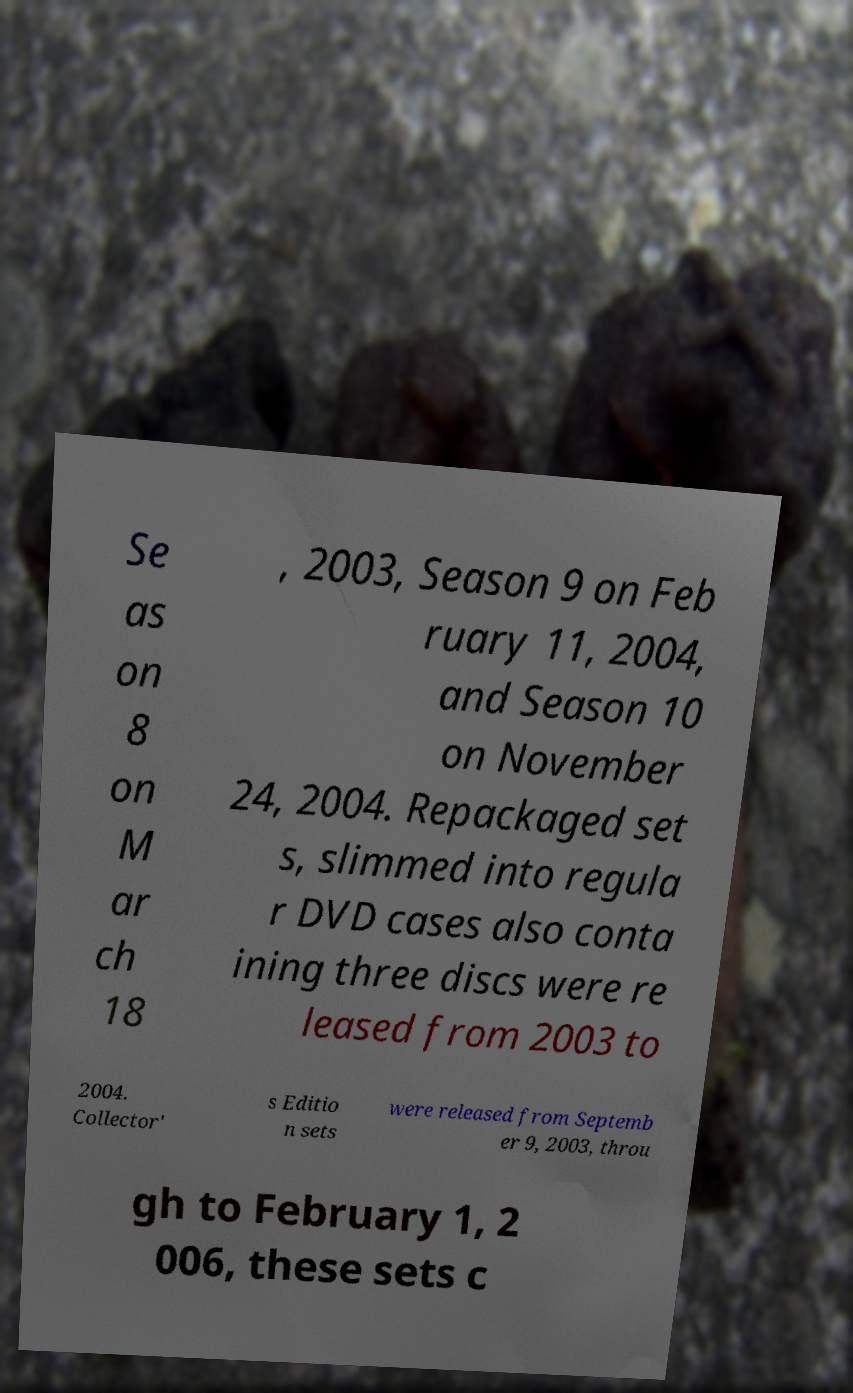Please read and relay the text visible in this image. What does it say? Se as on 8 on M ar ch 18 , 2003, Season 9 on Feb ruary 11, 2004, and Season 10 on November 24, 2004. Repackaged set s, slimmed into regula r DVD cases also conta ining three discs were re leased from 2003 to 2004. Collector' s Editio n sets were released from Septemb er 9, 2003, throu gh to February 1, 2 006, these sets c 